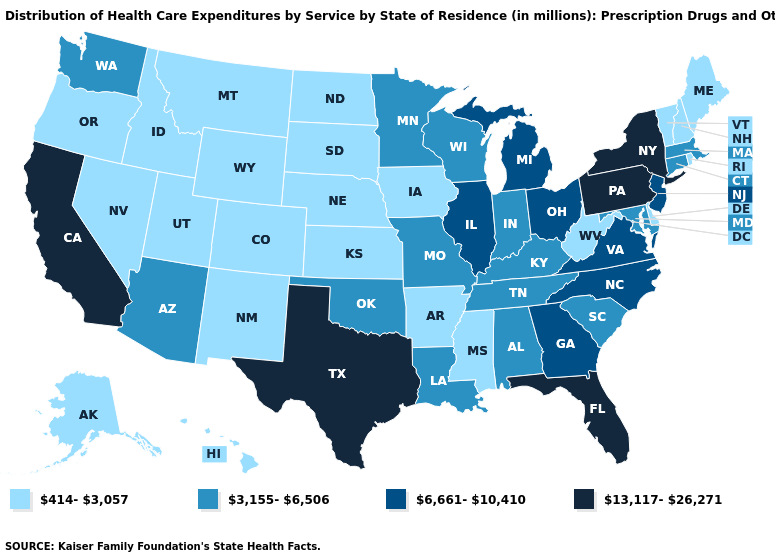Name the states that have a value in the range 3,155-6,506?
Short answer required. Alabama, Arizona, Connecticut, Indiana, Kentucky, Louisiana, Maryland, Massachusetts, Minnesota, Missouri, Oklahoma, South Carolina, Tennessee, Washington, Wisconsin. What is the value of Vermont?
Keep it brief. 414-3,057. What is the value of New Mexico?
Write a very short answer. 414-3,057. What is the value of Nebraska?
Be succinct. 414-3,057. What is the lowest value in the USA?
Give a very brief answer. 414-3,057. Among the states that border Iowa , does Minnesota have the highest value?
Answer briefly. No. Name the states that have a value in the range 6,661-10,410?
Quick response, please. Georgia, Illinois, Michigan, New Jersey, North Carolina, Ohio, Virginia. What is the value of South Carolina?
Answer briefly. 3,155-6,506. Does Illinois have a higher value than North Dakota?
Keep it brief. Yes. Name the states that have a value in the range 414-3,057?
Concise answer only. Alaska, Arkansas, Colorado, Delaware, Hawaii, Idaho, Iowa, Kansas, Maine, Mississippi, Montana, Nebraska, Nevada, New Hampshire, New Mexico, North Dakota, Oregon, Rhode Island, South Dakota, Utah, Vermont, West Virginia, Wyoming. What is the value of Connecticut?
Concise answer only. 3,155-6,506. What is the value of Louisiana?
Give a very brief answer. 3,155-6,506. Name the states that have a value in the range 13,117-26,271?
Concise answer only. California, Florida, New York, Pennsylvania, Texas. Among the states that border West Virginia , which have the lowest value?
Be succinct. Kentucky, Maryland. 